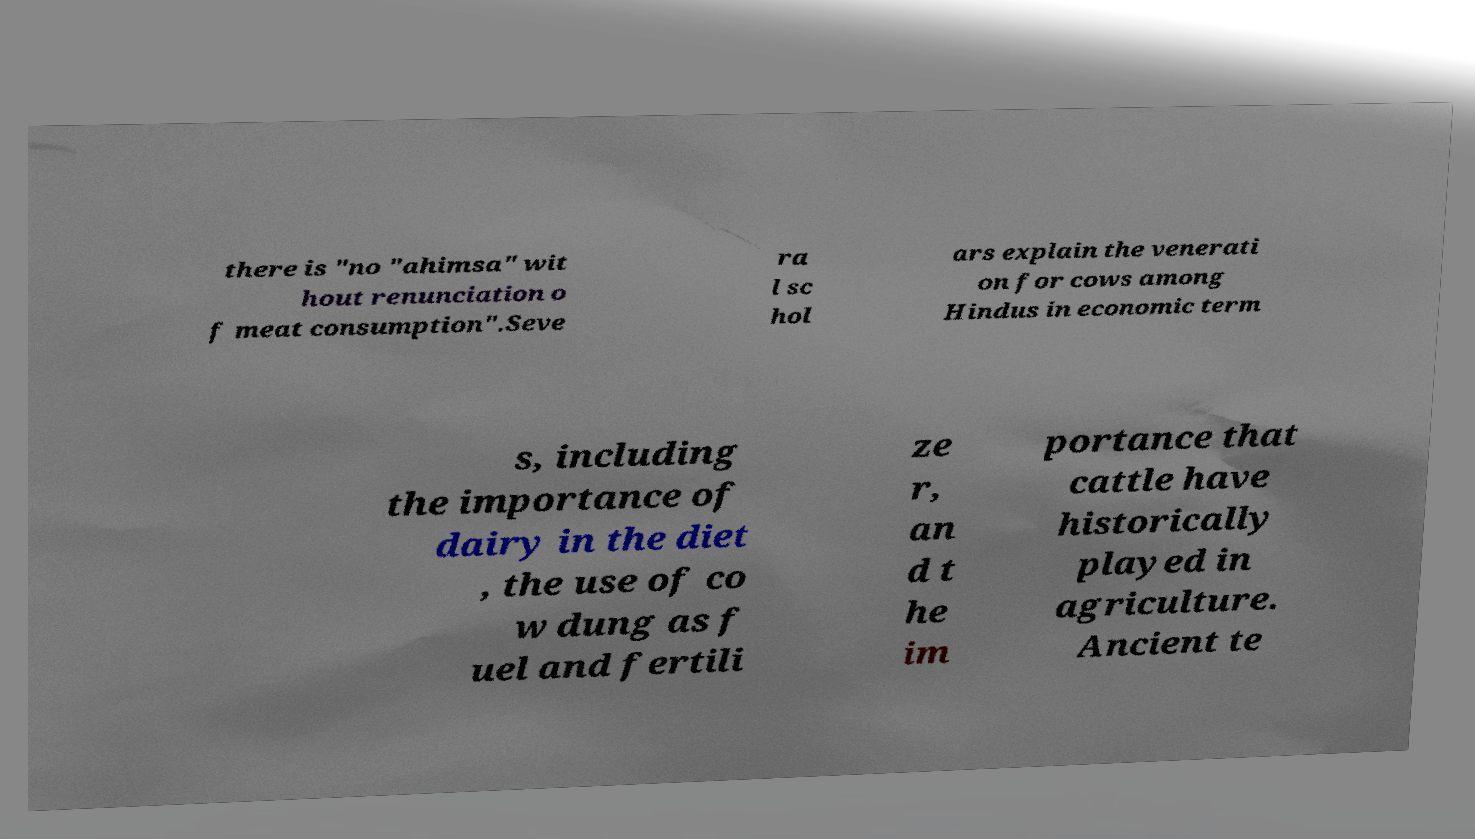I need the written content from this picture converted into text. Can you do that? there is "no "ahimsa" wit hout renunciation o f meat consumption".Seve ra l sc hol ars explain the venerati on for cows among Hindus in economic term s, including the importance of dairy in the diet , the use of co w dung as f uel and fertili ze r, an d t he im portance that cattle have historically played in agriculture. Ancient te 